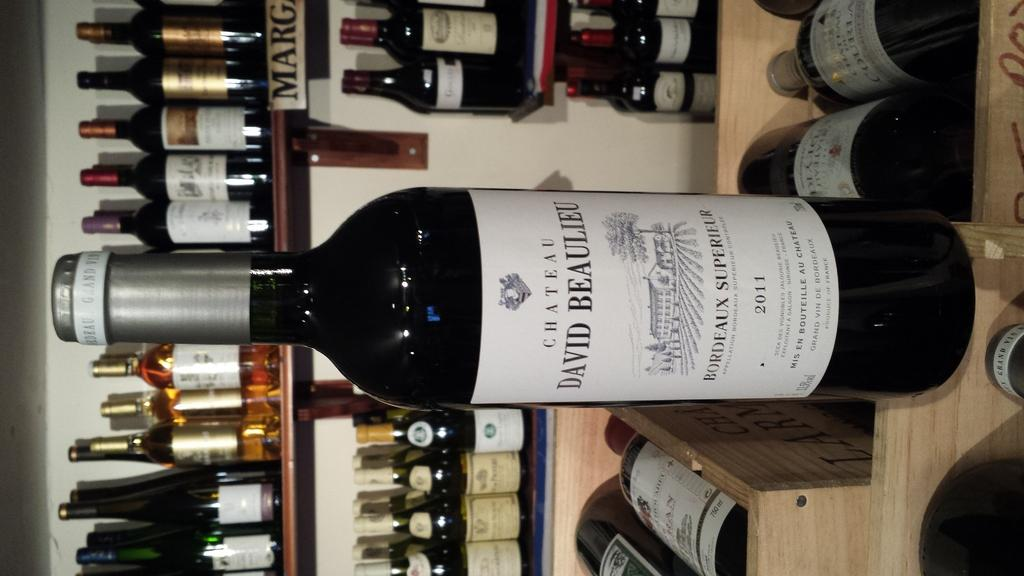What is on the table in the image? There is a wine bottle on the table. What can be seen in the background of the image? There is a wall and a shelf in the background of the image. What is on the shelf in the background? The shelf contains multiple wine bottles. Is there a cobweb visible on the wall in the image? There is no mention of a cobweb in the provided facts, so we cannot determine its presence from the image. 